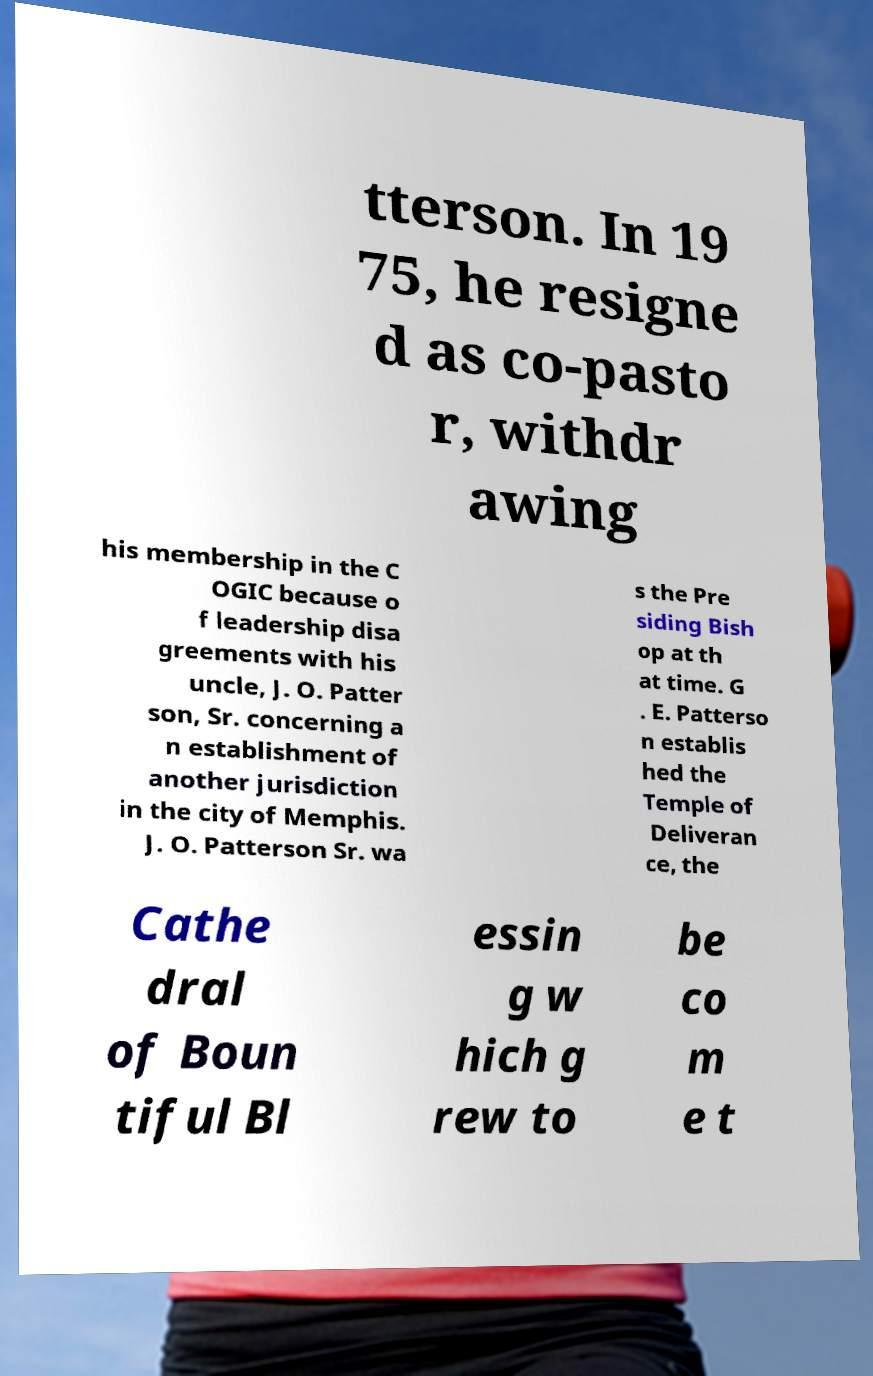Could you extract and type out the text from this image? tterson. In 19 75, he resigne d as co-pasto r, withdr awing his membership in the C OGIC because o f leadership disa greements with his uncle, J. O. Patter son, Sr. concerning a n establishment of another jurisdiction in the city of Memphis. J. O. Patterson Sr. wa s the Pre siding Bish op at th at time. G . E. Patterso n establis hed the Temple of Deliveran ce, the Cathe dral of Boun tiful Bl essin g w hich g rew to be co m e t 